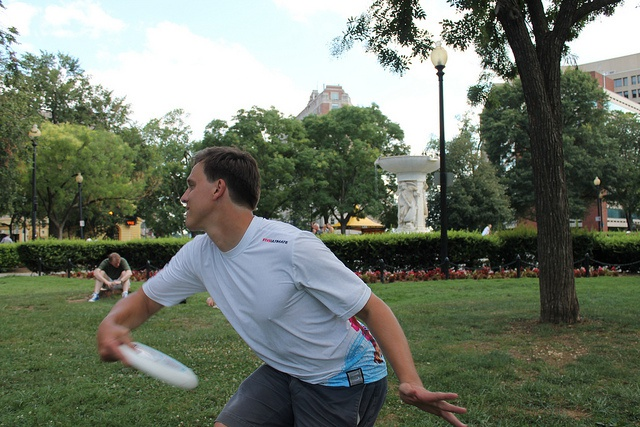Describe the objects in this image and their specific colors. I can see people in gray, darkgray, and black tones, frisbee in gray, darkgray, and lightgray tones, people in gray, black, and darkgray tones, and people in gray, lavender, darkgray, and lightblue tones in this image. 